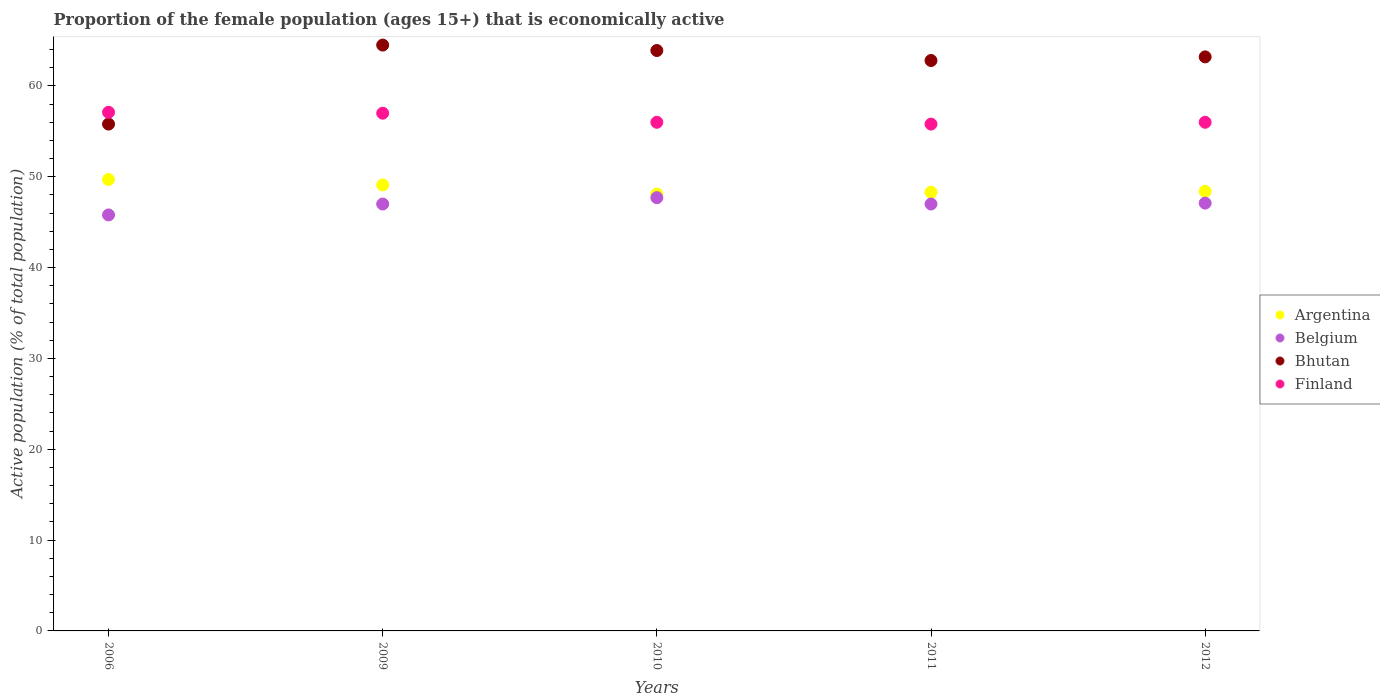How many different coloured dotlines are there?
Provide a short and direct response. 4. What is the proportion of the female population that is economically active in Argentina in 2012?
Offer a very short reply. 48.4. Across all years, what is the maximum proportion of the female population that is economically active in Belgium?
Give a very brief answer. 47.7. Across all years, what is the minimum proportion of the female population that is economically active in Finland?
Ensure brevity in your answer.  55.8. In which year was the proportion of the female population that is economically active in Belgium minimum?
Offer a terse response. 2006. What is the total proportion of the female population that is economically active in Argentina in the graph?
Your response must be concise. 243.6. What is the difference between the proportion of the female population that is economically active in Finland in 2006 and that in 2009?
Provide a short and direct response. 0.1. What is the difference between the proportion of the female population that is economically active in Argentina in 2006 and the proportion of the female population that is economically active in Belgium in 2011?
Your response must be concise. 2.7. What is the average proportion of the female population that is economically active in Bhutan per year?
Your response must be concise. 62.04. In the year 2011, what is the difference between the proportion of the female population that is economically active in Argentina and proportion of the female population that is economically active in Belgium?
Your response must be concise. 1.3. What is the ratio of the proportion of the female population that is economically active in Finland in 2006 to that in 2011?
Offer a very short reply. 1.02. Is the proportion of the female population that is economically active in Finland in 2006 less than that in 2009?
Your answer should be compact. No. Is the difference between the proportion of the female population that is economically active in Argentina in 2011 and 2012 greater than the difference between the proportion of the female population that is economically active in Belgium in 2011 and 2012?
Offer a very short reply. No. What is the difference between the highest and the second highest proportion of the female population that is economically active in Belgium?
Your response must be concise. 0.6. What is the difference between the highest and the lowest proportion of the female population that is economically active in Belgium?
Your response must be concise. 1.9. Is the sum of the proportion of the female population that is economically active in Argentina in 2006 and 2012 greater than the maximum proportion of the female population that is economically active in Belgium across all years?
Your response must be concise. Yes. Is it the case that in every year, the sum of the proportion of the female population that is economically active in Argentina and proportion of the female population that is economically active in Belgium  is greater than the proportion of the female population that is economically active in Bhutan?
Provide a succinct answer. Yes. How many dotlines are there?
Give a very brief answer. 4. Are the values on the major ticks of Y-axis written in scientific E-notation?
Give a very brief answer. No. Does the graph contain any zero values?
Ensure brevity in your answer.  No. Does the graph contain grids?
Your response must be concise. No. How many legend labels are there?
Provide a succinct answer. 4. What is the title of the graph?
Your answer should be very brief. Proportion of the female population (ages 15+) that is economically active. Does "Uganda" appear as one of the legend labels in the graph?
Your answer should be compact. No. What is the label or title of the X-axis?
Make the answer very short. Years. What is the label or title of the Y-axis?
Offer a very short reply. Active population (% of total population). What is the Active population (% of total population) in Argentina in 2006?
Provide a short and direct response. 49.7. What is the Active population (% of total population) in Belgium in 2006?
Your answer should be very brief. 45.8. What is the Active population (% of total population) in Bhutan in 2006?
Provide a succinct answer. 55.8. What is the Active population (% of total population) of Finland in 2006?
Your response must be concise. 57.1. What is the Active population (% of total population) in Argentina in 2009?
Make the answer very short. 49.1. What is the Active population (% of total population) of Belgium in 2009?
Offer a terse response. 47. What is the Active population (% of total population) of Bhutan in 2009?
Provide a short and direct response. 64.5. What is the Active population (% of total population) of Argentina in 2010?
Offer a very short reply. 48.1. What is the Active population (% of total population) in Belgium in 2010?
Give a very brief answer. 47.7. What is the Active population (% of total population) in Bhutan in 2010?
Your response must be concise. 63.9. What is the Active population (% of total population) in Argentina in 2011?
Ensure brevity in your answer.  48.3. What is the Active population (% of total population) of Bhutan in 2011?
Provide a short and direct response. 62.8. What is the Active population (% of total population) in Finland in 2011?
Your answer should be compact. 55.8. What is the Active population (% of total population) in Argentina in 2012?
Your answer should be compact. 48.4. What is the Active population (% of total population) in Belgium in 2012?
Provide a short and direct response. 47.1. What is the Active population (% of total population) of Bhutan in 2012?
Give a very brief answer. 63.2. What is the Active population (% of total population) in Finland in 2012?
Your answer should be very brief. 56. Across all years, what is the maximum Active population (% of total population) of Argentina?
Offer a terse response. 49.7. Across all years, what is the maximum Active population (% of total population) in Belgium?
Make the answer very short. 47.7. Across all years, what is the maximum Active population (% of total population) of Bhutan?
Provide a short and direct response. 64.5. Across all years, what is the maximum Active population (% of total population) in Finland?
Your response must be concise. 57.1. Across all years, what is the minimum Active population (% of total population) in Argentina?
Make the answer very short. 48.1. Across all years, what is the minimum Active population (% of total population) in Belgium?
Give a very brief answer. 45.8. Across all years, what is the minimum Active population (% of total population) in Bhutan?
Your answer should be very brief. 55.8. Across all years, what is the minimum Active population (% of total population) in Finland?
Provide a short and direct response. 55.8. What is the total Active population (% of total population) of Argentina in the graph?
Make the answer very short. 243.6. What is the total Active population (% of total population) of Belgium in the graph?
Offer a very short reply. 234.6. What is the total Active population (% of total population) of Bhutan in the graph?
Offer a very short reply. 310.2. What is the total Active population (% of total population) in Finland in the graph?
Your response must be concise. 281.9. What is the difference between the Active population (% of total population) of Argentina in 2006 and that in 2009?
Make the answer very short. 0.6. What is the difference between the Active population (% of total population) in Belgium in 2006 and that in 2009?
Keep it short and to the point. -1.2. What is the difference between the Active population (% of total population) in Finland in 2006 and that in 2009?
Your answer should be compact. 0.1. What is the difference between the Active population (% of total population) in Argentina in 2006 and that in 2010?
Your response must be concise. 1.6. What is the difference between the Active population (% of total population) in Belgium in 2006 and that in 2010?
Offer a very short reply. -1.9. What is the difference between the Active population (% of total population) in Finland in 2006 and that in 2010?
Give a very brief answer. 1.1. What is the difference between the Active population (% of total population) in Argentina in 2006 and that in 2011?
Ensure brevity in your answer.  1.4. What is the difference between the Active population (% of total population) in Argentina in 2006 and that in 2012?
Your answer should be very brief. 1.3. What is the difference between the Active population (% of total population) of Belgium in 2006 and that in 2012?
Ensure brevity in your answer.  -1.3. What is the difference between the Active population (% of total population) of Argentina in 2009 and that in 2010?
Make the answer very short. 1. What is the difference between the Active population (% of total population) in Bhutan in 2009 and that in 2010?
Offer a terse response. 0.6. What is the difference between the Active population (% of total population) of Finland in 2009 and that in 2010?
Offer a very short reply. 1. What is the difference between the Active population (% of total population) in Belgium in 2009 and that in 2011?
Offer a terse response. 0. What is the difference between the Active population (% of total population) in Finland in 2009 and that in 2011?
Offer a very short reply. 1.2. What is the difference between the Active population (% of total population) of Argentina in 2010 and that in 2011?
Keep it short and to the point. -0.2. What is the difference between the Active population (% of total population) in Belgium in 2010 and that in 2011?
Your response must be concise. 0.7. What is the difference between the Active population (% of total population) in Bhutan in 2010 and that in 2011?
Your response must be concise. 1.1. What is the difference between the Active population (% of total population) in Belgium in 2010 and that in 2012?
Offer a very short reply. 0.6. What is the difference between the Active population (% of total population) in Argentina in 2011 and that in 2012?
Your answer should be compact. -0.1. What is the difference between the Active population (% of total population) of Finland in 2011 and that in 2012?
Your answer should be very brief. -0.2. What is the difference between the Active population (% of total population) of Argentina in 2006 and the Active population (% of total population) of Belgium in 2009?
Ensure brevity in your answer.  2.7. What is the difference between the Active population (% of total population) in Argentina in 2006 and the Active population (% of total population) in Bhutan in 2009?
Make the answer very short. -14.8. What is the difference between the Active population (% of total population) of Belgium in 2006 and the Active population (% of total population) of Bhutan in 2009?
Offer a terse response. -18.7. What is the difference between the Active population (% of total population) of Belgium in 2006 and the Active population (% of total population) of Finland in 2009?
Give a very brief answer. -11.2. What is the difference between the Active population (% of total population) of Argentina in 2006 and the Active population (% of total population) of Belgium in 2010?
Your answer should be compact. 2. What is the difference between the Active population (% of total population) of Argentina in 2006 and the Active population (% of total population) of Finland in 2010?
Offer a terse response. -6.3. What is the difference between the Active population (% of total population) in Belgium in 2006 and the Active population (% of total population) in Bhutan in 2010?
Provide a short and direct response. -18.1. What is the difference between the Active population (% of total population) of Bhutan in 2006 and the Active population (% of total population) of Finland in 2010?
Keep it short and to the point. -0.2. What is the difference between the Active population (% of total population) of Argentina in 2006 and the Active population (% of total population) of Belgium in 2011?
Your answer should be compact. 2.7. What is the difference between the Active population (% of total population) of Argentina in 2006 and the Active population (% of total population) of Bhutan in 2011?
Provide a short and direct response. -13.1. What is the difference between the Active population (% of total population) of Argentina in 2006 and the Active population (% of total population) of Finland in 2011?
Ensure brevity in your answer.  -6.1. What is the difference between the Active population (% of total population) in Belgium in 2006 and the Active population (% of total population) in Finland in 2011?
Keep it short and to the point. -10. What is the difference between the Active population (% of total population) of Argentina in 2006 and the Active population (% of total population) of Bhutan in 2012?
Provide a short and direct response. -13.5. What is the difference between the Active population (% of total population) of Argentina in 2006 and the Active population (% of total population) of Finland in 2012?
Give a very brief answer. -6.3. What is the difference between the Active population (% of total population) in Belgium in 2006 and the Active population (% of total population) in Bhutan in 2012?
Your answer should be very brief. -17.4. What is the difference between the Active population (% of total population) of Belgium in 2006 and the Active population (% of total population) of Finland in 2012?
Provide a short and direct response. -10.2. What is the difference between the Active population (% of total population) in Argentina in 2009 and the Active population (% of total population) in Bhutan in 2010?
Provide a short and direct response. -14.8. What is the difference between the Active population (% of total population) of Belgium in 2009 and the Active population (% of total population) of Bhutan in 2010?
Your answer should be very brief. -16.9. What is the difference between the Active population (% of total population) in Belgium in 2009 and the Active population (% of total population) in Finland in 2010?
Ensure brevity in your answer.  -9. What is the difference between the Active population (% of total population) of Argentina in 2009 and the Active population (% of total population) of Bhutan in 2011?
Give a very brief answer. -13.7. What is the difference between the Active population (% of total population) in Belgium in 2009 and the Active population (% of total population) in Bhutan in 2011?
Give a very brief answer. -15.8. What is the difference between the Active population (% of total population) of Belgium in 2009 and the Active population (% of total population) of Finland in 2011?
Your answer should be very brief. -8.8. What is the difference between the Active population (% of total population) in Bhutan in 2009 and the Active population (% of total population) in Finland in 2011?
Keep it short and to the point. 8.7. What is the difference between the Active population (% of total population) of Argentina in 2009 and the Active population (% of total population) of Belgium in 2012?
Your response must be concise. 2. What is the difference between the Active population (% of total population) in Argentina in 2009 and the Active population (% of total population) in Bhutan in 2012?
Provide a succinct answer. -14.1. What is the difference between the Active population (% of total population) of Belgium in 2009 and the Active population (% of total population) of Bhutan in 2012?
Offer a very short reply. -16.2. What is the difference between the Active population (% of total population) of Belgium in 2009 and the Active population (% of total population) of Finland in 2012?
Your answer should be very brief. -9. What is the difference between the Active population (% of total population) in Argentina in 2010 and the Active population (% of total population) in Belgium in 2011?
Your answer should be compact. 1.1. What is the difference between the Active population (% of total population) in Argentina in 2010 and the Active population (% of total population) in Bhutan in 2011?
Your answer should be very brief. -14.7. What is the difference between the Active population (% of total population) of Argentina in 2010 and the Active population (% of total population) of Finland in 2011?
Make the answer very short. -7.7. What is the difference between the Active population (% of total population) in Belgium in 2010 and the Active population (% of total population) in Bhutan in 2011?
Your answer should be compact. -15.1. What is the difference between the Active population (% of total population) in Bhutan in 2010 and the Active population (% of total population) in Finland in 2011?
Your response must be concise. 8.1. What is the difference between the Active population (% of total population) in Argentina in 2010 and the Active population (% of total population) in Belgium in 2012?
Provide a short and direct response. 1. What is the difference between the Active population (% of total population) in Argentina in 2010 and the Active population (% of total population) in Bhutan in 2012?
Make the answer very short. -15.1. What is the difference between the Active population (% of total population) in Belgium in 2010 and the Active population (% of total population) in Bhutan in 2012?
Your answer should be compact. -15.5. What is the difference between the Active population (% of total population) in Belgium in 2010 and the Active population (% of total population) in Finland in 2012?
Your answer should be compact. -8.3. What is the difference between the Active population (% of total population) of Bhutan in 2010 and the Active population (% of total population) of Finland in 2012?
Your response must be concise. 7.9. What is the difference between the Active population (% of total population) in Argentina in 2011 and the Active population (% of total population) in Belgium in 2012?
Ensure brevity in your answer.  1.2. What is the difference between the Active population (% of total population) in Argentina in 2011 and the Active population (% of total population) in Bhutan in 2012?
Your response must be concise. -14.9. What is the difference between the Active population (% of total population) in Belgium in 2011 and the Active population (% of total population) in Bhutan in 2012?
Your response must be concise. -16.2. What is the difference between the Active population (% of total population) of Belgium in 2011 and the Active population (% of total population) of Finland in 2012?
Your answer should be compact. -9. What is the difference between the Active population (% of total population) of Bhutan in 2011 and the Active population (% of total population) of Finland in 2012?
Offer a terse response. 6.8. What is the average Active population (% of total population) of Argentina per year?
Provide a short and direct response. 48.72. What is the average Active population (% of total population) of Belgium per year?
Ensure brevity in your answer.  46.92. What is the average Active population (% of total population) in Bhutan per year?
Your answer should be compact. 62.04. What is the average Active population (% of total population) in Finland per year?
Give a very brief answer. 56.38. In the year 2006, what is the difference between the Active population (% of total population) in Belgium and Active population (% of total population) in Bhutan?
Provide a succinct answer. -10. In the year 2006, what is the difference between the Active population (% of total population) of Bhutan and Active population (% of total population) of Finland?
Your response must be concise. -1.3. In the year 2009, what is the difference between the Active population (% of total population) in Argentina and Active population (% of total population) in Belgium?
Provide a succinct answer. 2.1. In the year 2009, what is the difference between the Active population (% of total population) of Argentina and Active population (% of total population) of Bhutan?
Make the answer very short. -15.4. In the year 2009, what is the difference between the Active population (% of total population) of Argentina and Active population (% of total population) of Finland?
Your response must be concise. -7.9. In the year 2009, what is the difference between the Active population (% of total population) of Belgium and Active population (% of total population) of Bhutan?
Provide a short and direct response. -17.5. In the year 2009, what is the difference between the Active population (% of total population) of Belgium and Active population (% of total population) of Finland?
Offer a very short reply. -10. In the year 2010, what is the difference between the Active population (% of total population) in Argentina and Active population (% of total population) in Belgium?
Make the answer very short. 0.4. In the year 2010, what is the difference between the Active population (% of total population) in Argentina and Active population (% of total population) in Bhutan?
Keep it short and to the point. -15.8. In the year 2010, what is the difference between the Active population (% of total population) of Belgium and Active population (% of total population) of Bhutan?
Your answer should be compact. -16.2. In the year 2011, what is the difference between the Active population (% of total population) of Argentina and Active population (% of total population) of Bhutan?
Your response must be concise. -14.5. In the year 2011, what is the difference between the Active population (% of total population) of Argentina and Active population (% of total population) of Finland?
Provide a short and direct response. -7.5. In the year 2011, what is the difference between the Active population (% of total population) in Belgium and Active population (% of total population) in Bhutan?
Keep it short and to the point. -15.8. In the year 2011, what is the difference between the Active population (% of total population) of Bhutan and Active population (% of total population) of Finland?
Keep it short and to the point. 7. In the year 2012, what is the difference between the Active population (% of total population) in Argentina and Active population (% of total population) in Bhutan?
Ensure brevity in your answer.  -14.8. In the year 2012, what is the difference between the Active population (% of total population) in Argentina and Active population (% of total population) in Finland?
Offer a very short reply. -7.6. In the year 2012, what is the difference between the Active population (% of total population) in Belgium and Active population (% of total population) in Bhutan?
Give a very brief answer. -16.1. In the year 2012, what is the difference between the Active population (% of total population) of Belgium and Active population (% of total population) of Finland?
Provide a succinct answer. -8.9. In the year 2012, what is the difference between the Active population (% of total population) in Bhutan and Active population (% of total population) in Finland?
Your response must be concise. 7.2. What is the ratio of the Active population (% of total population) in Argentina in 2006 to that in 2009?
Your answer should be very brief. 1.01. What is the ratio of the Active population (% of total population) of Belgium in 2006 to that in 2009?
Keep it short and to the point. 0.97. What is the ratio of the Active population (% of total population) in Bhutan in 2006 to that in 2009?
Offer a terse response. 0.87. What is the ratio of the Active population (% of total population) of Finland in 2006 to that in 2009?
Ensure brevity in your answer.  1. What is the ratio of the Active population (% of total population) of Argentina in 2006 to that in 2010?
Your answer should be very brief. 1.03. What is the ratio of the Active population (% of total population) in Belgium in 2006 to that in 2010?
Give a very brief answer. 0.96. What is the ratio of the Active population (% of total population) in Bhutan in 2006 to that in 2010?
Offer a very short reply. 0.87. What is the ratio of the Active population (% of total population) in Finland in 2006 to that in 2010?
Your answer should be compact. 1.02. What is the ratio of the Active population (% of total population) in Argentina in 2006 to that in 2011?
Ensure brevity in your answer.  1.03. What is the ratio of the Active population (% of total population) of Belgium in 2006 to that in 2011?
Provide a succinct answer. 0.97. What is the ratio of the Active population (% of total population) in Bhutan in 2006 to that in 2011?
Your answer should be very brief. 0.89. What is the ratio of the Active population (% of total population) of Finland in 2006 to that in 2011?
Provide a short and direct response. 1.02. What is the ratio of the Active population (% of total population) of Argentina in 2006 to that in 2012?
Your response must be concise. 1.03. What is the ratio of the Active population (% of total population) in Belgium in 2006 to that in 2012?
Offer a very short reply. 0.97. What is the ratio of the Active population (% of total population) of Bhutan in 2006 to that in 2012?
Keep it short and to the point. 0.88. What is the ratio of the Active population (% of total population) of Finland in 2006 to that in 2012?
Ensure brevity in your answer.  1.02. What is the ratio of the Active population (% of total population) in Argentina in 2009 to that in 2010?
Your answer should be very brief. 1.02. What is the ratio of the Active population (% of total population) in Belgium in 2009 to that in 2010?
Keep it short and to the point. 0.99. What is the ratio of the Active population (% of total population) in Bhutan in 2009 to that in 2010?
Offer a very short reply. 1.01. What is the ratio of the Active population (% of total population) of Finland in 2009 to that in 2010?
Your answer should be compact. 1.02. What is the ratio of the Active population (% of total population) of Argentina in 2009 to that in 2011?
Ensure brevity in your answer.  1.02. What is the ratio of the Active population (% of total population) in Belgium in 2009 to that in 2011?
Your response must be concise. 1. What is the ratio of the Active population (% of total population) in Bhutan in 2009 to that in 2011?
Your answer should be very brief. 1.03. What is the ratio of the Active population (% of total population) in Finland in 2009 to that in 2011?
Offer a terse response. 1.02. What is the ratio of the Active population (% of total population) of Argentina in 2009 to that in 2012?
Provide a short and direct response. 1.01. What is the ratio of the Active population (% of total population) in Belgium in 2009 to that in 2012?
Your answer should be compact. 1. What is the ratio of the Active population (% of total population) of Bhutan in 2009 to that in 2012?
Your answer should be very brief. 1.02. What is the ratio of the Active population (% of total population) in Finland in 2009 to that in 2012?
Offer a terse response. 1.02. What is the ratio of the Active population (% of total population) in Belgium in 2010 to that in 2011?
Give a very brief answer. 1.01. What is the ratio of the Active population (% of total population) of Bhutan in 2010 to that in 2011?
Give a very brief answer. 1.02. What is the ratio of the Active population (% of total population) in Belgium in 2010 to that in 2012?
Keep it short and to the point. 1.01. What is the ratio of the Active population (% of total population) in Bhutan in 2010 to that in 2012?
Your answer should be very brief. 1.01. What is the ratio of the Active population (% of total population) in Argentina in 2011 to that in 2012?
Your answer should be compact. 1. What is the ratio of the Active population (% of total population) in Belgium in 2011 to that in 2012?
Your response must be concise. 1. What is the ratio of the Active population (% of total population) in Finland in 2011 to that in 2012?
Offer a terse response. 1. What is the difference between the highest and the second highest Active population (% of total population) of Bhutan?
Your response must be concise. 0.6. What is the difference between the highest and the second highest Active population (% of total population) of Finland?
Your answer should be compact. 0.1. What is the difference between the highest and the lowest Active population (% of total population) of Argentina?
Provide a succinct answer. 1.6. What is the difference between the highest and the lowest Active population (% of total population) in Belgium?
Offer a terse response. 1.9. What is the difference between the highest and the lowest Active population (% of total population) of Bhutan?
Your response must be concise. 8.7. 